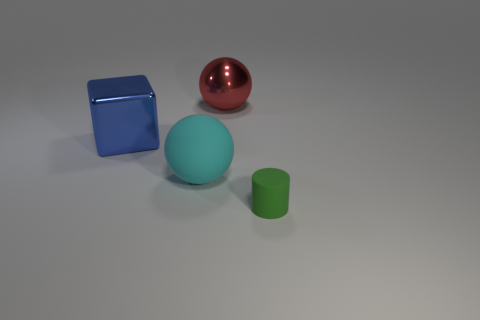There is a green object; does it have the same size as the rubber object to the left of the green matte thing?
Offer a terse response. No. There is a large sphere behind the shiny thing that is in front of the red shiny object; what is its color?
Your answer should be compact. Red. How many things are either things behind the green cylinder or large objects behind the large cube?
Provide a succinct answer. 3. Does the red metallic object have the same size as the green matte cylinder?
Your answer should be compact. No. Is there anything else that is the same size as the green matte cylinder?
Make the answer very short. No. There is a big thing right of the big rubber ball; does it have the same shape as the rubber object that is on the left side of the tiny matte cylinder?
Your answer should be compact. Yes. What size is the metallic cube?
Your answer should be compact. Large. What is the material of the big object that is behind the metallic thing on the left side of the sphere that is to the left of the large metal sphere?
Your answer should be very brief. Metal. How many other things are the same color as the rubber cylinder?
Provide a succinct answer. 0. What number of blue things are either balls or blocks?
Ensure brevity in your answer.  1. 